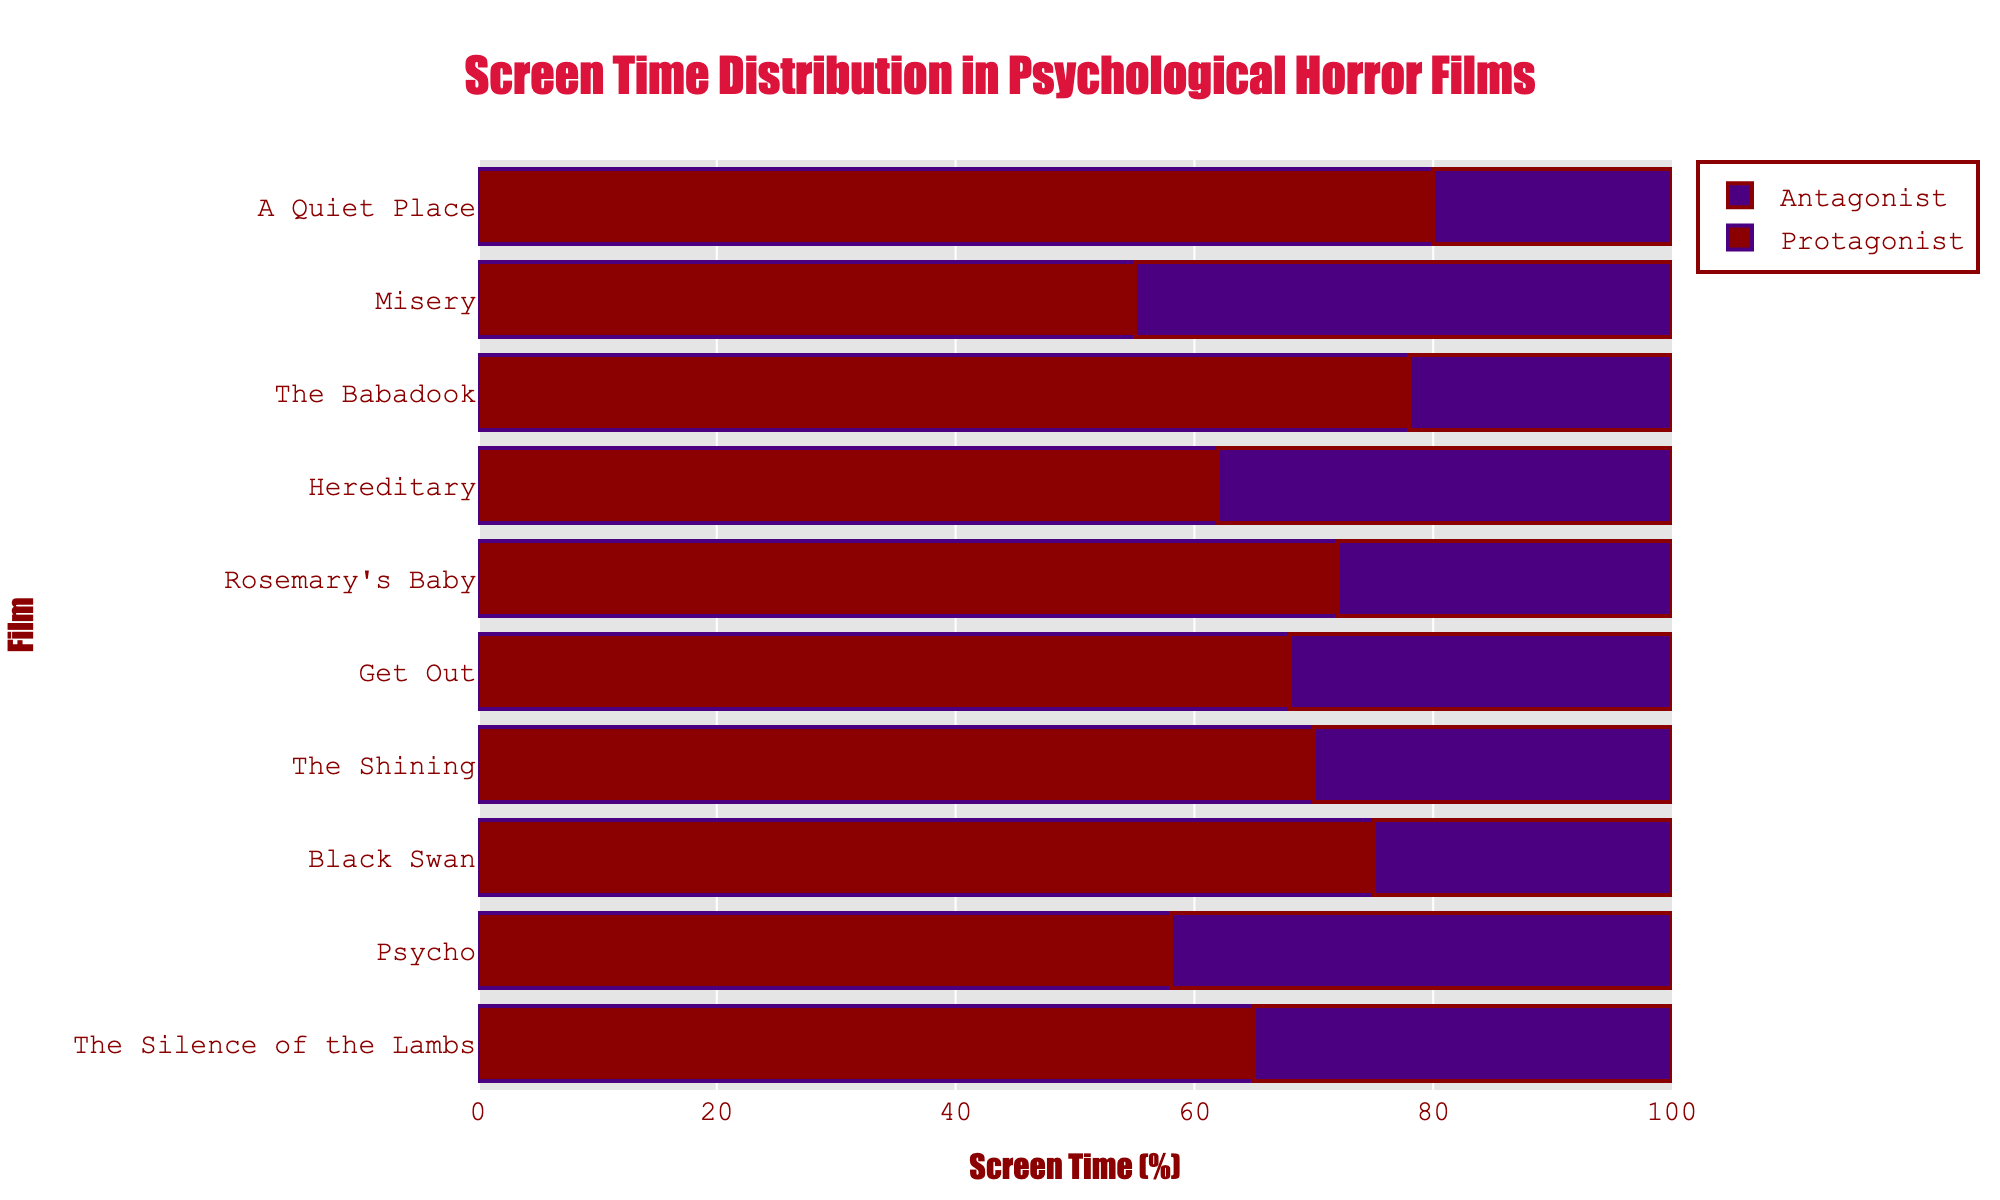What is the title of the figure? The title is placed at the top of the figure and it reads "Screen Time Distribution in Psychological Horror Films".
Answer: Screen Time Distribution in Psychological Horror Films Which film has the highest screen time for the protagonist? The film with the largest protagonist bar, reaching 80%, represents "A Quiet Place".
Answer: A Quiet Place What's the average screen time percentage of antagonists across all films? Sum all the antagonist screen time percentages and divide by the number of films: (35 + 42 + 25 + 30 + 32 + 28 + 38 + 22 + 45 + 20) = 317; average = 317 / 10 = 31.7%.
Answer: 31.7% How much more screen time does the protagonist have compared to the antagonist in "Rosemary's Baby"? The protagonist has 72% and the antagonist has 28%. The difference is 72% - 28% = 44%.
Answer: 44% Between "Hereditary" and "Misery", which film has a greater screen time for its antagonist and by how much? "Hereditary" has 38% antagonist screen time and "Misery" has 45%. The difference is 45% - 38% = 7%.
Answer: Misery by 7% What is the color of the bars representing the antagonist screen time? The bars representing the antagonist screen time are colored in purple.
Answer: Purple Which film shows an almost equal screen time for both protagonist and antagonist? "Misery" is the film where the protagonist and antagonist screen times are closest, with 55% for the protagonist and 45% for the antagonist.
Answer: Misery What is the range of values on the x-axis? The x-axis ranges from 0 to 100 as it represents percentages.
Answer: 0 to 100 What is the total screen time percentage for both protagonist and antagonist in "The Shining"? The protagonist has 70% and the antagonist has 30%. Adding these gives 70% + 30% = 100%.
Answer: 100% Which film has the closest screen time ratio between protagonist and antagonist among "The Silence of the Lambs," "Psycho," and "Hereditary"? Comparing "The Silence of the Lambs" (65% vs. 35%), "Psycho" (58% vs. 42%), and "Hereditary" (62% vs. 38%) shows "Psycho" has the closest ratio.
Answer: Psycho 